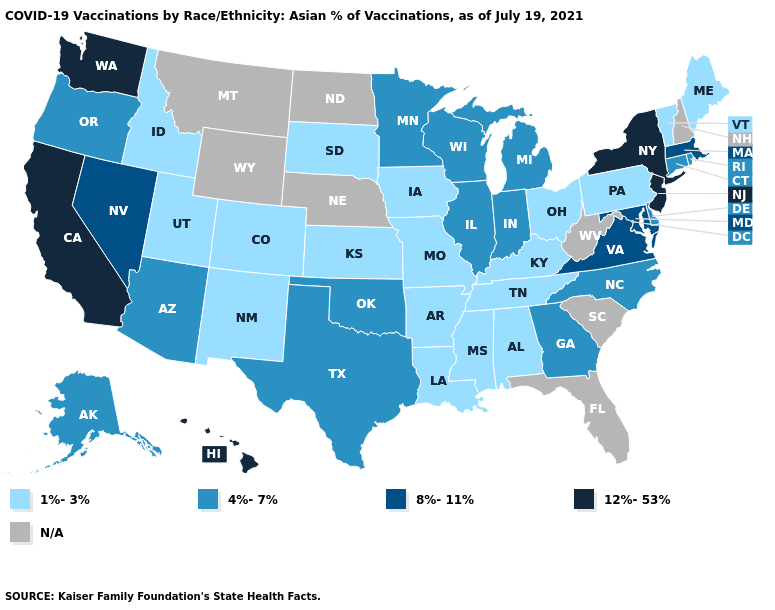Among the states that border Vermont , does Massachusetts have the highest value?
Answer briefly. No. Name the states that have a value in the range 1%-3%?
Answer briefly. Alabama, Arkansas, Colorado, Idaho, Iowa, Kansas, Kentucky, Louisiana, Maine, Mississippi, Missouri, New Mexico, Ohio, Pennsylvania, South Dakota, Tennessee, Utah, Vermont. Does the first symbol in the legend represent the smallest category?
Short answer required. Yes. Name the states that have a value in the range 4%-7%?
Quick response, please. Alaska, Arizona, Connecticut, Delaware, Georgia, Illinois, Indiana, Michigan, Minnesota, North Carolina, Oklahoma, Oregon, Rhode Island, Texas, Wisconsin. What is the value of Nevada?
Quick response, please. 8%-11%. What is the highest value in states that border North Carolina?
Give a very brief answer. 8%-11%. What is the value of Rhode Island?
Short answer required. 4%-7%. What is the highest value in the MidWest ?
Short answer required. 4%-7%. Name the states that have a value in the range 12%-53%?
Answer briefly. California, Hawaii, New Jersey, New York, Washington. Does Arkansas have the highest value in the South?
Give a very brief answer. No. What is the highest value in the USA?
Be succinct. 12%-53%. Does Maryland have the highest value in the South?
Concise answer only. Yes. Does Virginia have the highest value in the South?
Keep it brief. Yes. Which states have the lowest value in the USA?
Be succinct. Alabama, Arkansas, Colorado, Idaho, Iowa, Kansas, Kentucky, Louisiana, Maine, Mississippi, Missouri, New Mexico, Ohio, Pennsylvania, South Dakota, Tennessee, Utah, Vermont. 